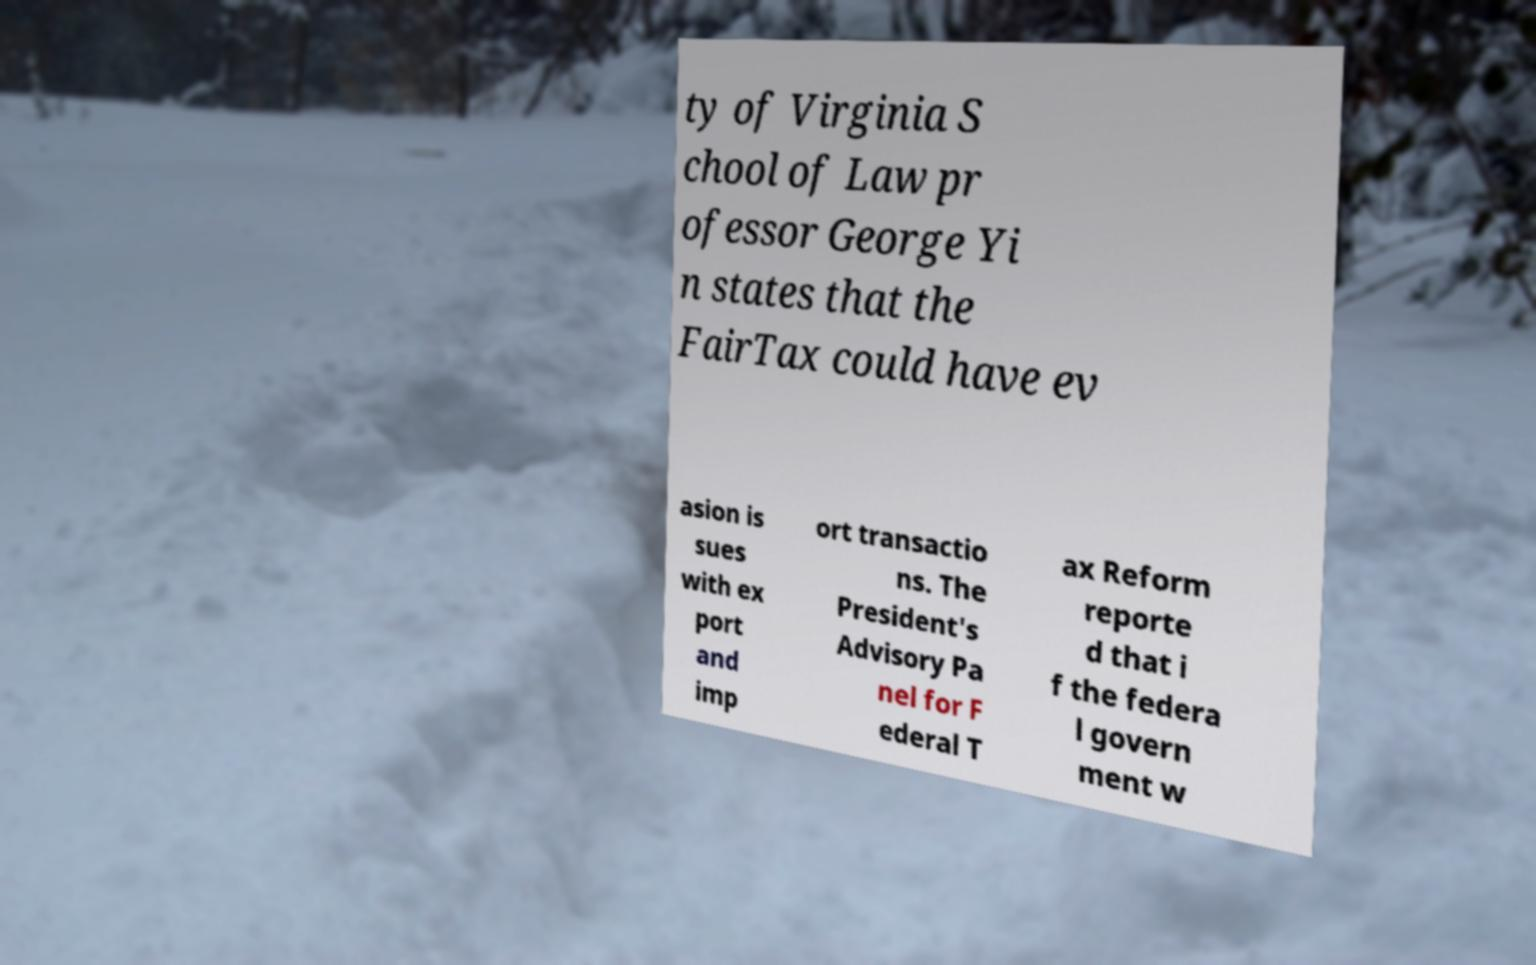What messages or text are displayed in this image? I need them in a readable, typed format. ty of Virginia S chool of Law pr ofessor George Yi n states that the FairTax could have ev asion is sues with ex port and imp ort transactio ns. The President's Advisory Pa nel for F ederal T ax Reform reporte d that i f the federa l govern ment w 